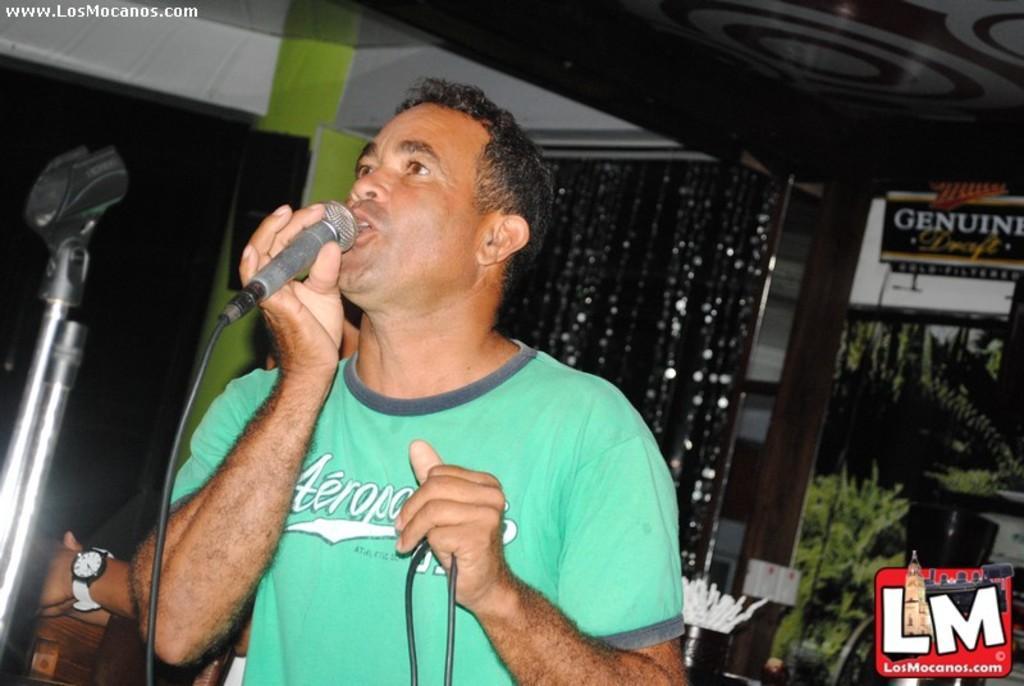Please provide a concise description of this image. In the above pictures the person is standing and singing holding a mic in his right hand and in the left hand he is holding a wire. The mic stand is in front of him and in the back ground there is decorative curtain and decorative design ceiling and there is person at the back of him having a black colored t shirt and having a wrist watch on his hand. There is green colored wall at the back of him. 